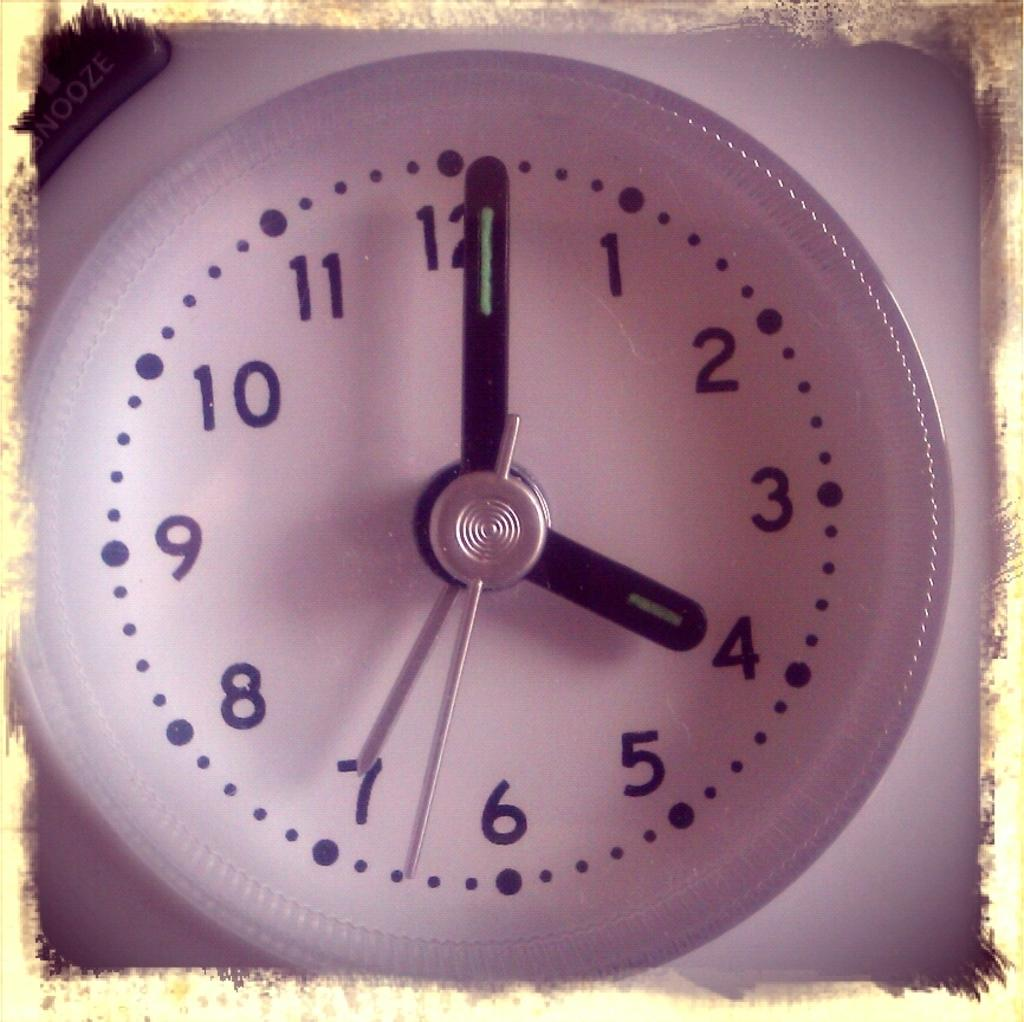<image>
Offer a succinct explanation of the picture presented. The clock shows that it is one minute past 4. 